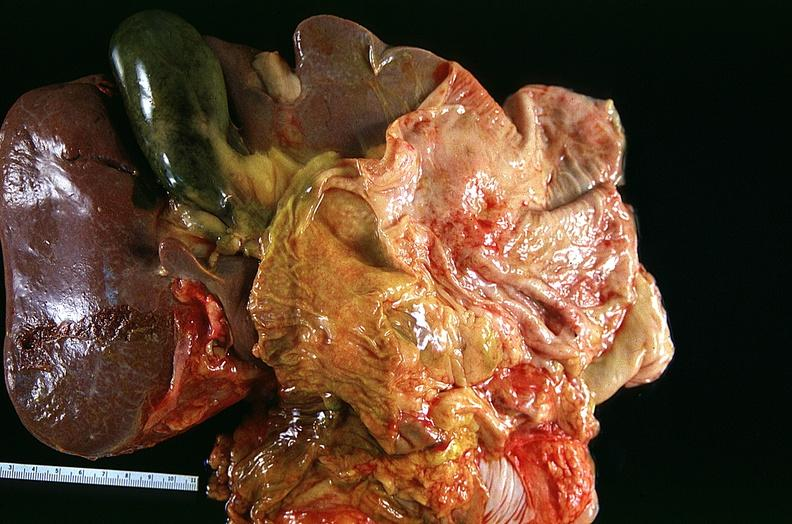s respiratory present?
Answer the question using a single word or phrase. Yes 